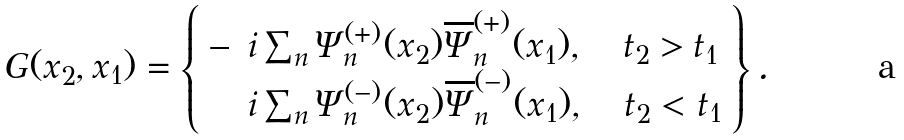<formula> <loc_0><loc_0><loc_500><loc_500>G ( x _ { 2 } , x _ { 1 } ) = \left \{ \begin{array} { l l } - & i \sum _ { n } \Psi _ { n } ^ { ( + ) } ( x _ { 2 } ) \overline { \Psi } _ { n } ^ { ( + ) } ( x _ { 1 } ) , \quad t _ { 2 } > t _ { 1 } \\ & i \sum _ { n } \Psi _ { n } ^ { ( - ) } ( x _ { 2 } ) \overline { \Psi } _ { n } ^ { ( - ) } ( x _ { 1 } ) , \quad t _ { 2 } < t _ { 1 } \end{array} \right \} .</formula> 